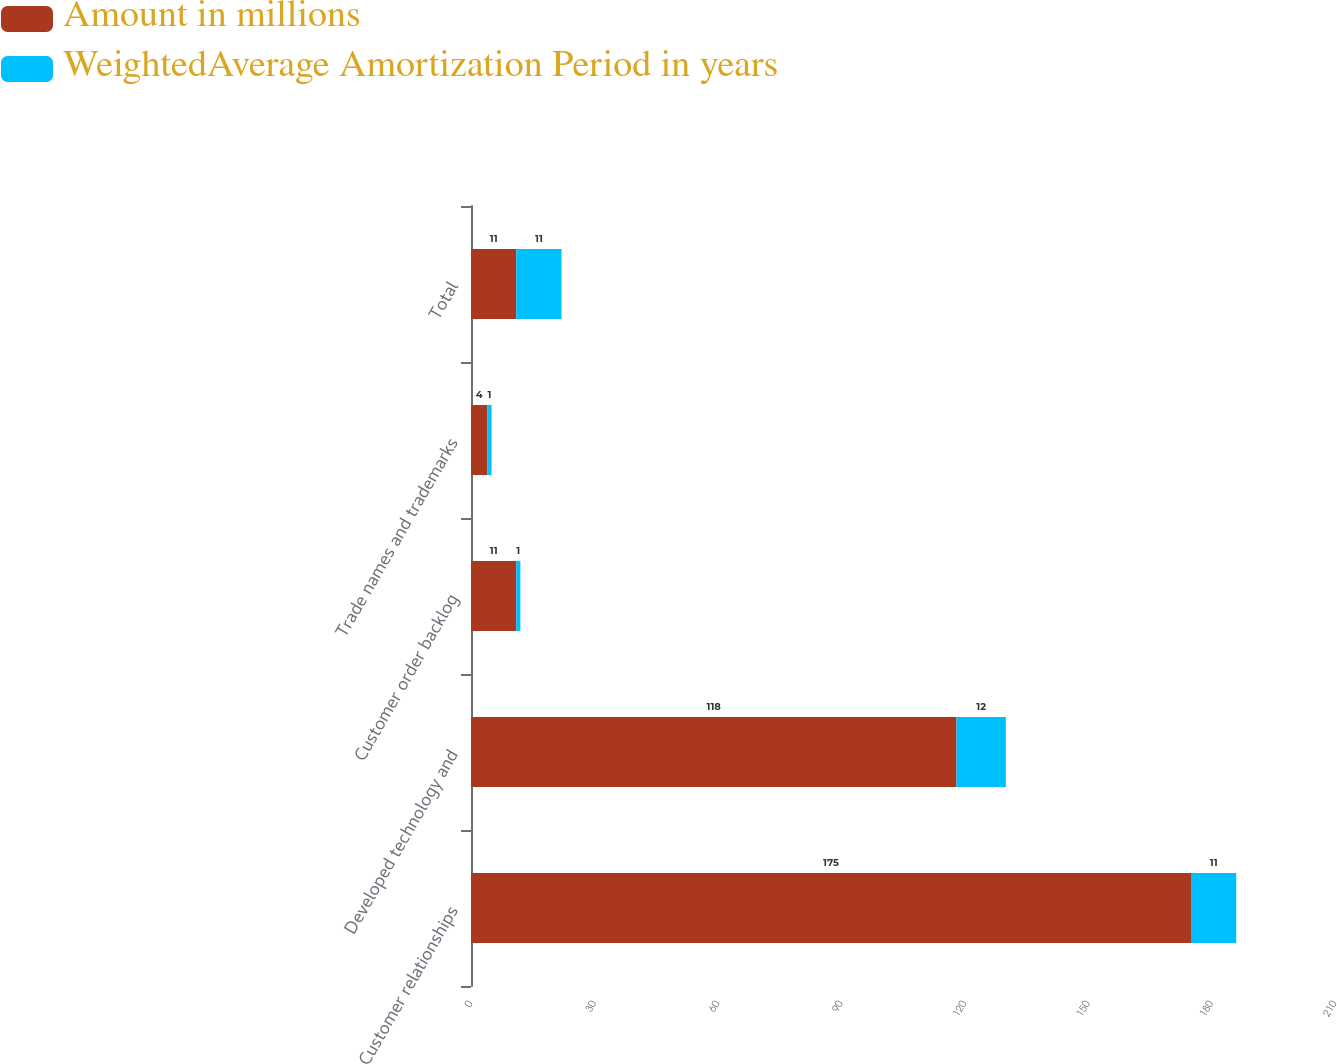Convert chart to OTSL. <chart><loc_0><loc_0><loc_500><loc_500><stacked_bar_chart><ecel><fcel>Customer relationships<fcel>Developed technology and<fcel>Customer order backlog<fcel>Trade names and trademarks<fcel>Total<nl><fcel>Amount in millions<fcel>175<fcel>118<fcel>11<fcel>4<fcel>11<nl><fcel>WeightedAverage Amortization Period in years<fcel>11<fcel>12<fcel>1<fcel>1<fcel>11<nl></chart> 